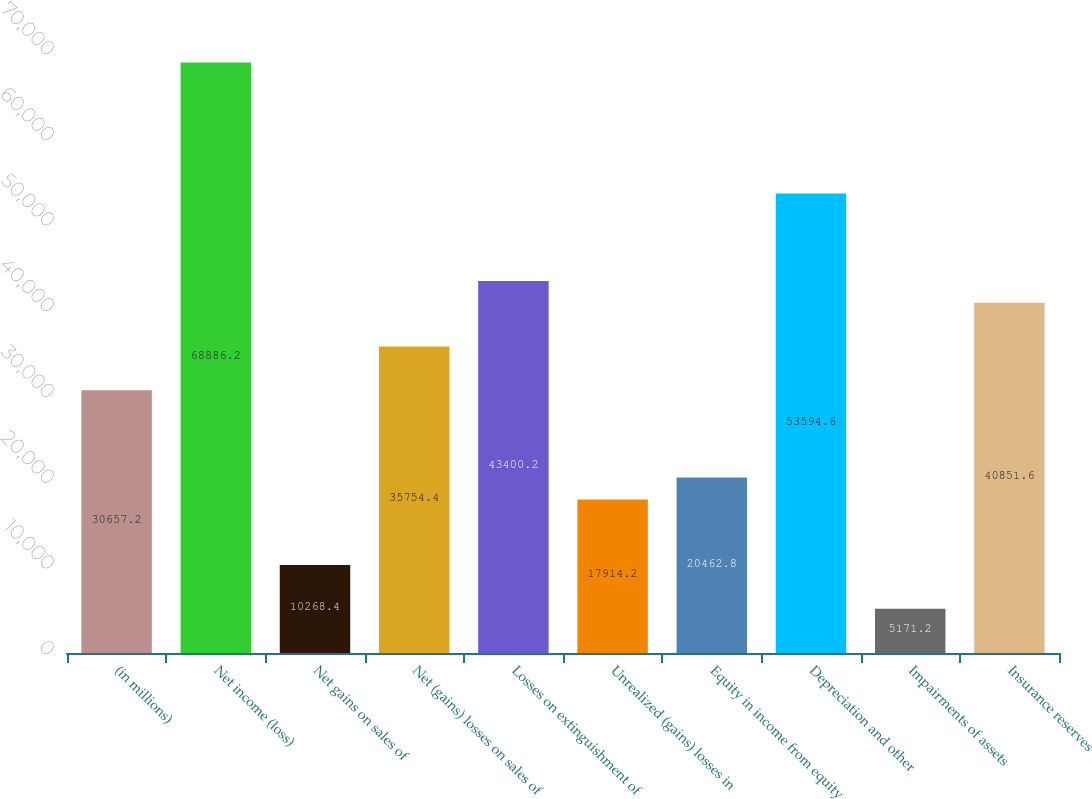<chart> <loc_0><loc_0><loc_500><loc_500><bar_chart><fcel>(in millions)<fcel>Net income (loss)<fcel>Net gains on sales of<fcel>Net (gains) losses on sales of<fcel>Losses on extinguishment of<fcel>Unrealized (gains) losses in<fcel>Equity in income from equity<fcel>Depreciation and other<fcel>Impairments of assets<fcel>Insurance reserves<nl><fcel>30657.2<fcel>68886.2<fcel>10268.4<fcel>35754.4<fcel>43400.2<fcel>17914.2<fcel>20462.8<fcel>53594.6<fcel>5171.2<fcel>40851.6<nl></chart> 